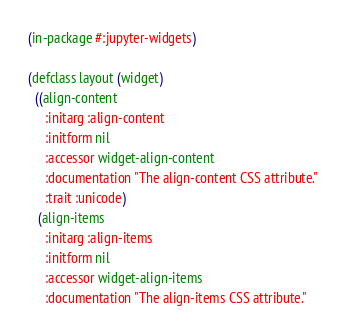<code> <loc_0><loc_0><loc_500><loc_500><_Lisp_>(in-package #:jupyter-widgets)

(defclass layout (widget)
  ((align-content
     :initarg :align-content
     :initform nil
     :accessor widget-align-content
     :documentation "The align-content CSS attribute."
     :trait :unicode)
   (align-items
     :initarg :align-items
     :initform nil
     :accessor widget-align-items
     :documentation "The align-items CSS attribute."</code> 